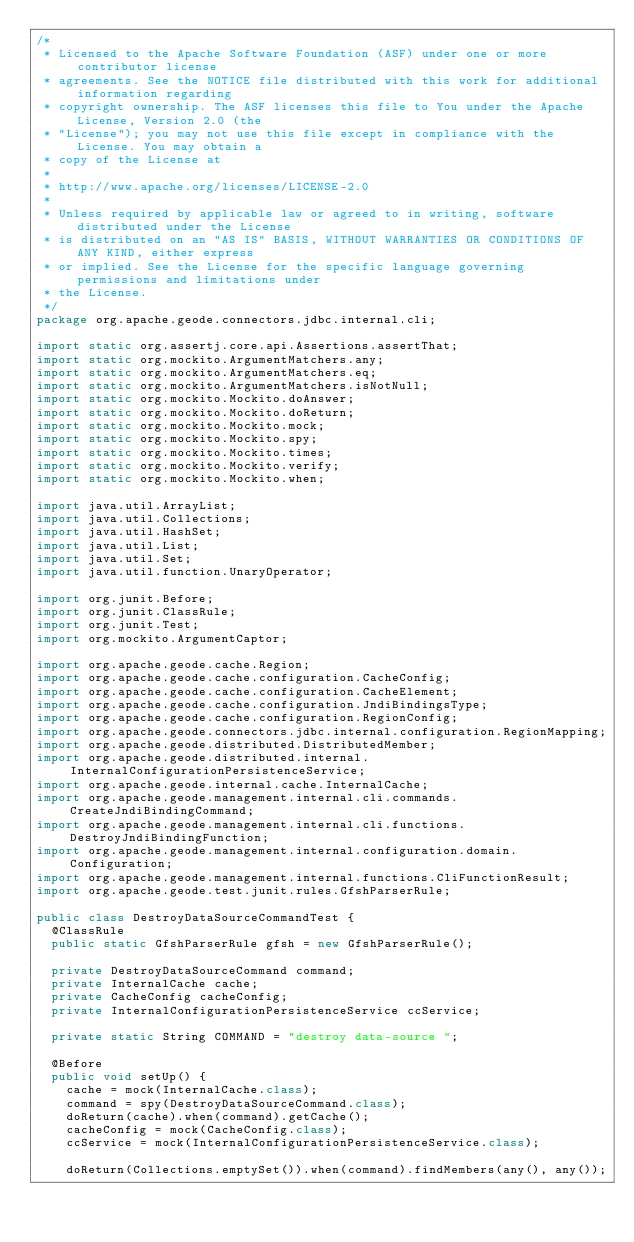<code> <loc_0><loc_0><loc_500><loc_500><_Java_>/*
 * Licensed to the Apache Software Foundation (ASF) under one or more contributor license
 * agreements. See the NOTICE file distributed with this work for additional information regarding
 * copyright ownership. The ASF licenses this file to You under the Apache License, Version 2.0 (the
 * "License"); you may not use this file except in compliance with the License. You may obtain a
 * copy of the License at
 *
 * http://www.apache.org/licenses/LICENSE-2.0
 *
 * Unless required by applicable law or agreed to in writing, software distributed under the License
 * is distributed on an "AS IS" BASIS, WITHOUT WARRANTIES OR CONDITIONS OF ANY KIND, either express
 * or implied. See the License for the specific language governing permissions and limitations under
 * the License.
 */
package org.apache.geode.connectors.jdbc.internal.cli;

import static org.assertj.core.api.Assertions.assertThat;
import static org.mockito.ArgumentMatchers.any;
import static org.mockito.ArgumentMatchers.eq;
import static org.mockito.ArgumentMatchers.isNotNull;
import static org.mockito.Mockito.doAnswer;
import static org.mockito.Mockito.doReturn;
import static org.mockito.Mockito.mock;
import static org.mockito.Mockito.spy;
import static org.mockito.Mockito.times;
import static org.mockito.Mockito.verify;
import static org.mockito.Mockito.when;

import java.util.ArrayList;
import java.util.Collections;
import java.util.HashSet;
import java.util.List;
import java.util.Set;
import java.util.function.UnaryOperator;

import org.junit.Before;
import org.junit.ClassRule;
import org.junit.Test;
import org.mockito.ArgumentCaptor;

import org.apache.geode.cache.Region;
import org.apache.geode.cache.configuration.CacheConfig;
import org.apache.geode.cache.configuration.CacheElement;
import org.apache.geode.cache.configuration.JndiBindingsType;
import org.apache.geode.cache.configuration.RegionConfig;
import org.apache.geode.connectors.jdbc.internal.configuration.RegionMapping;
import org.apache.geode.distributed.DistributedMember;
import org.apache.geode.distributed.internal.InternalConfigurationPersistenceService;
import org.apache.geode.internal.cache.InternalCache;
import org.apache.geode.management.internal.cli.commands.CreateJndiBindingCommand;
import org.apache.geode.management.internal.cli.functions.DestroyJndiBindingFunction;
import org.apache.geode.management.internal.configuration.domain.Configuration;
import org.apache.geode.management.internal.functions.CliFunctionResult;
import org.apache.geode.test.junit.rules.GfshParserRule;

public class DestroyDataSourceCommandTest {
  @ClassRule
  public static GfshParserRule gfsh = new GfshParserRule();

  private DestroyDataSourceCommand command;
  private InternalCache cache;
  private CacheConfig cacheConfig;
  private InternalConfigurationPersistenceService ccService;

  private static String COMMAND = "destroy data-source ";

  @Before
  public void setUp() {
    cache = mock(InternalCache.class);
    command = spy(DestroyDataSourceCommand.class);
    doReturn(cache).when(command).getCache();
    cacheConfig = mock(CacheConfig.class);
    ccService = mock(InternalConfigurationPersistenceService.class);

    doReturn(Collections.emptySet()).when(command).findMembers(any(), any());</code> 